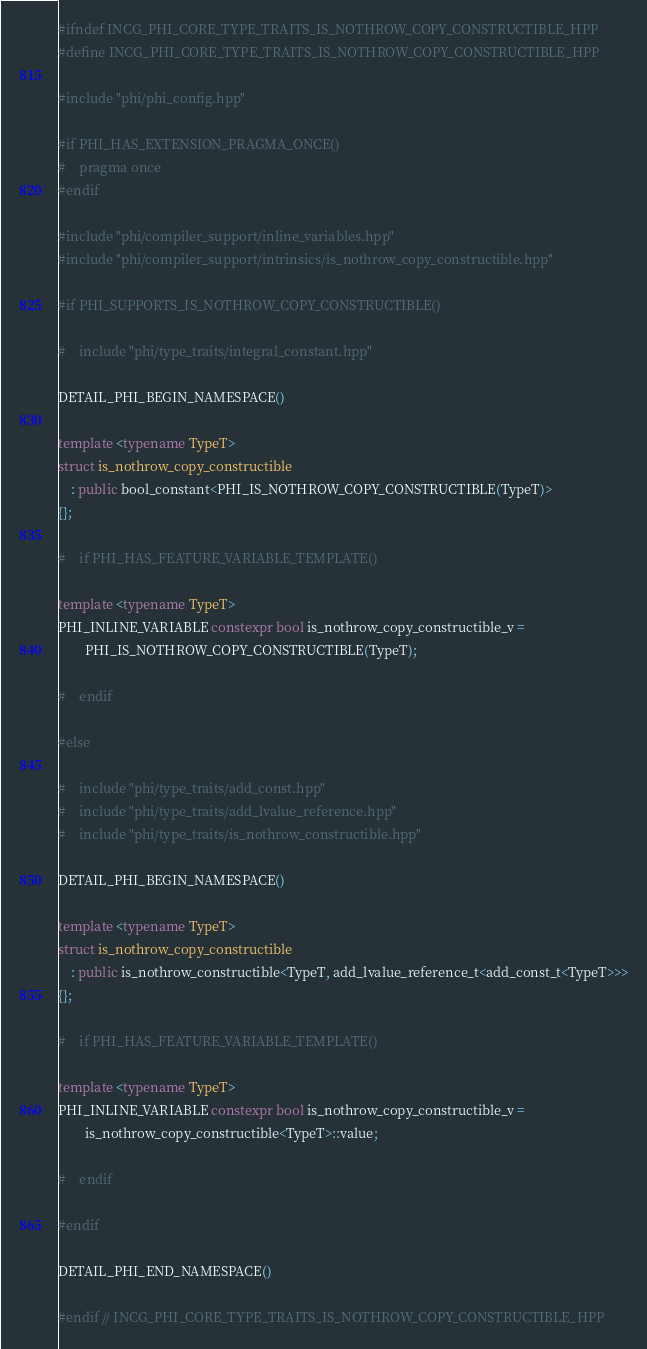Convert code to text. <code><loc_0><loc_0><loc_500><loc_500><_C++_>#ifndef INCG_PHI_CORE_TYPE_TRAITS_IS_NOTHROW_COPY_CONSTRUCTIBLE_HPP
#define INCG_PHI_CORE_TYPE_TRAITS_IS_NOTHROW_COPY_CONSTRUCTIBLE_HPP

#include "phi/phi_config.hpp"

#if PHI_HAS_EXTENSION_PRAGMA_ONCE()
#    pragma once
#endif

#include "phi/compiler_support/inline_variables.hpp"
#include "phi/compiler_support/intrinsics/is_nothrow_copy_constructible.hpp"

#if PHI_SUPPORTS_IS_NOTHROW_COPY_CONSTRUCTIBLE()

#    include "phi/type_traits/integral_constant.hpp"

DETAIL_PHI_BEGIN_NAMESPACE()

template <typename TypeT>
struct is_nothrow_copy_constructible
    : public bool_constant<PHI_IS_NOTHROW_COPY_CONSTRUCTIBLE(TypeT)>
{};

#    if PHI_HAS_FEATURE_VARIABLE_TEMPLATE()

template <typename TypeT>
PHI_INLINE_VARIABLE constexpr bool is_nothrow_copy_constructible_v =
        PHI_IS_NOTHROW_COPY_CONSTRUCTIBLE(TypeT);

#    endif

#else

#    include "phi/type_traits/add_const.hpp"
#    include "phi/type_traits/add_lvalue_reference.hpp"
#    include "phi/type_traits/is_nothrow_constructible.hpp"

DETAIL_PHI_BEGIN_NAMESPACE()

template <typename TypeT>
struct is_nothrow_copy_constructible
    : public is_nothrow_constructible<TypeT, add_lvalue_reference_t<add_const_t<TypeT>>>
{};

#    if PHI_HAS_FEATURE_VARIABLE_TEMPLATE()

template <typename TypeT>
PHI_INLINE_VARIABLE constexpr bool is_nothrow_copy_constructible_v =
        is_nothrow_copy_constructible<TypeT>::value;

#    endif

#endif

DETAIL_PHI_END_NAMESPACE()

#endif // INCG_PHI_CORE_TYPE_TRAITS_IS_NOTHROW_COPY_CONSTRUCTIBLE_HPP
</code> 